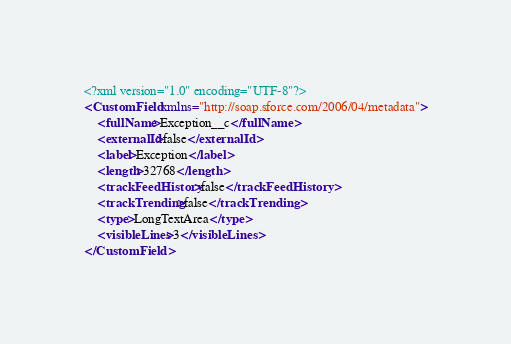<code> <loc_0><loc_0><loc_500><loc_500><_XML_><?xml version="1.0" encoding="UTF-8"?>
<CustomField xmlns="http://soap.sforce.com/2006/04/metadata">
    <fullName>Exception__c</fullName>
    <externalId>false</externalId>
    <label>Exception</label>
    <length>32768</length>
    <trackFeedHistory>false</trackFeedHistory>
    <trackTrending>false</trackTrending>
    <type>LongTextArea</type>
    <visibleLines>3</visibleLines>
</CustomField>
</code> 